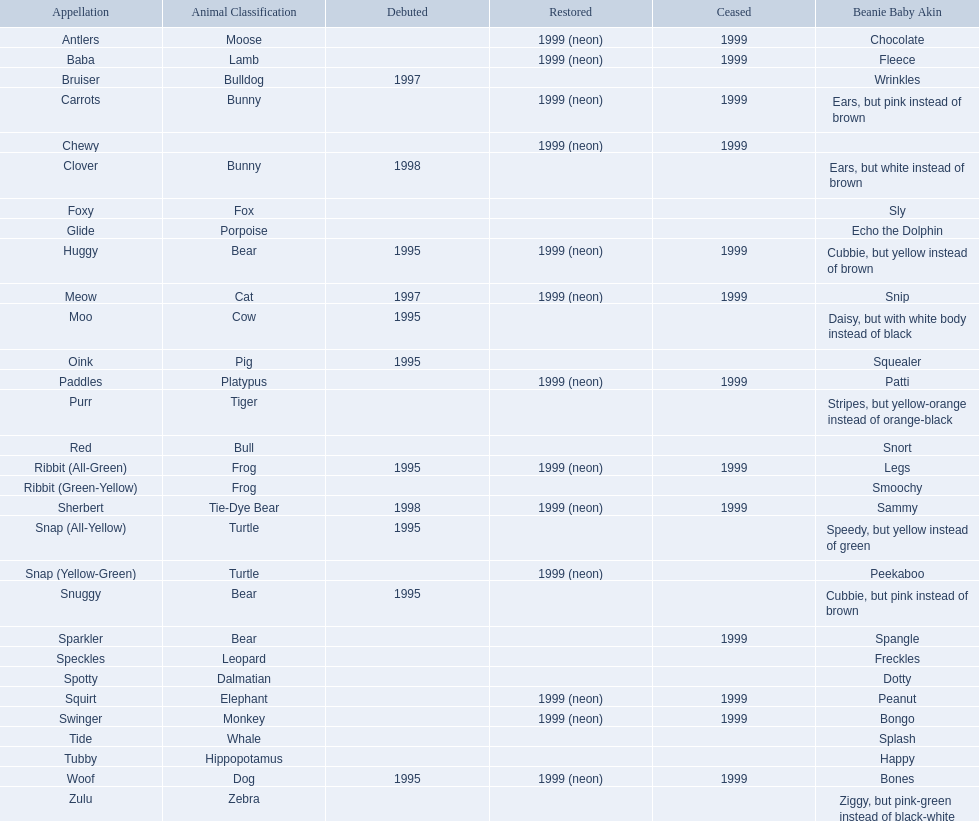Which of the listed pillow pals lack information in at least 3 categories? Chewy, Foxy, Glide, Purr, Red, Ribbit (Green-Yellow), Speckles, Spotty, Tide, Tubby, Zulu. Of those, which one lacks information in the animal type category? Chewy. 